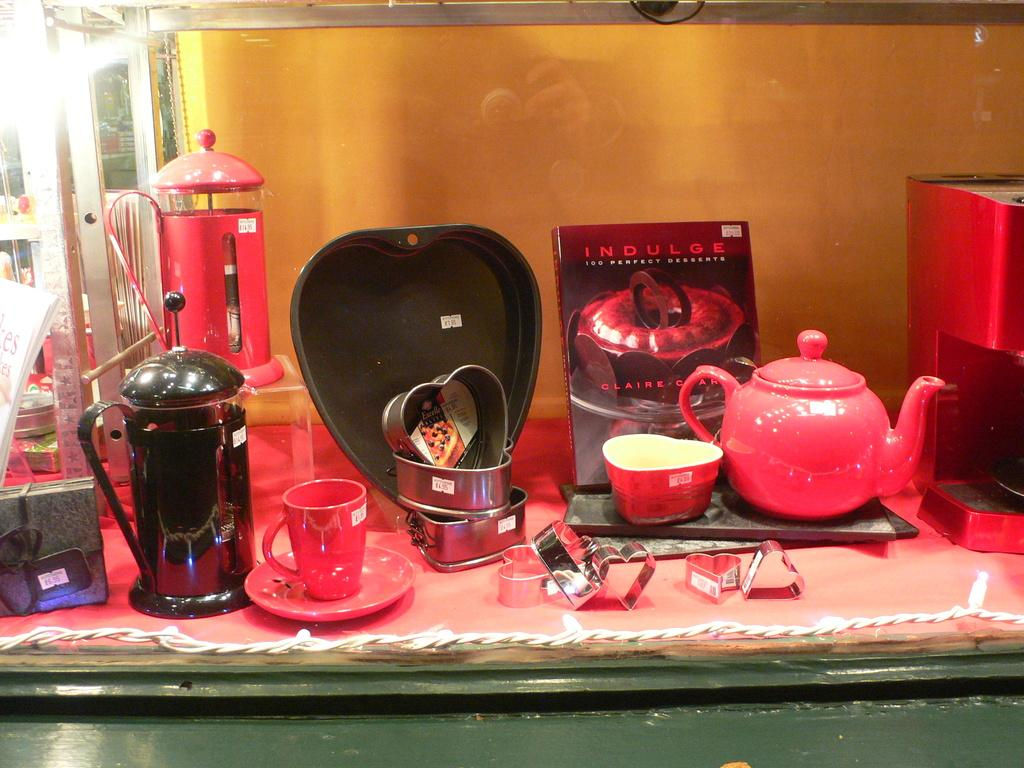<image>
Give a short and clear explanation of the subsequent image. a display of a tea set, with a book titled "indulge" behind the pot 